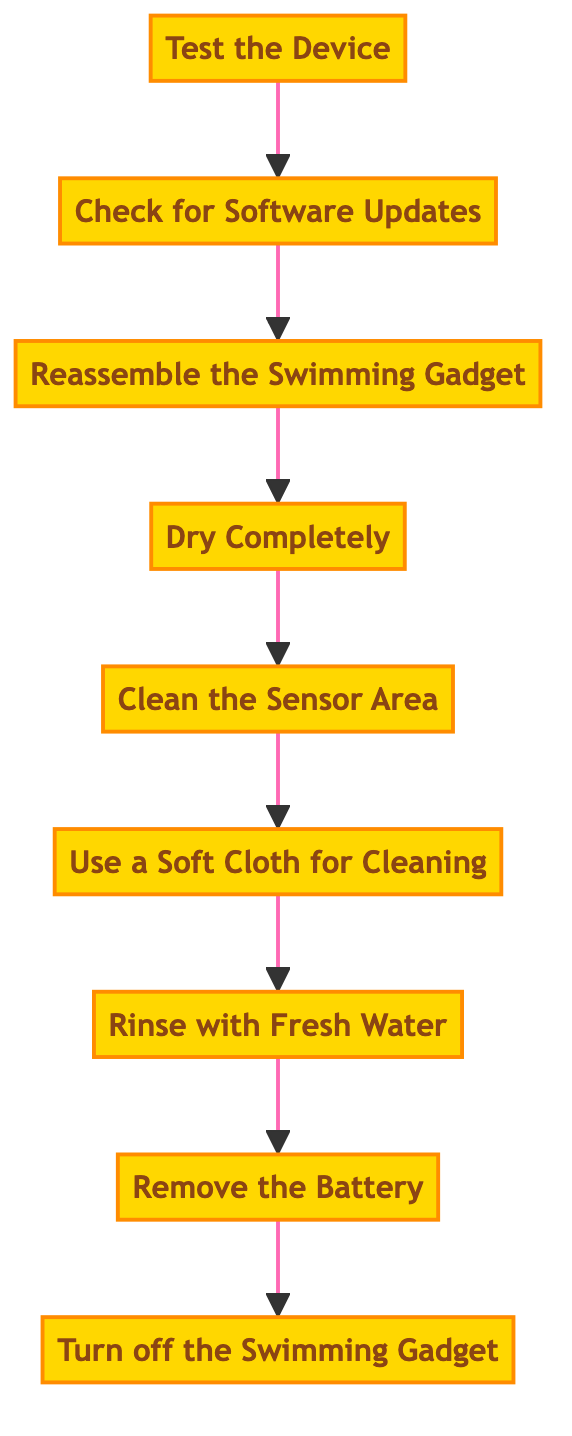What is the first step in the process? The first step in the flow chart is identified at the bottom, which is "Turn off the Swimming Gadget."
Answer: Turn off the Swimming Gadget How many steps are in the maintenance and cleaning process? By counting all listed steps in the flow chart from bottom to top, there are a total of nine distinct steps outlined in the process.
Answer: 9 What should you do before cleaning the device? The instruction before cleaning, according to the flow, is to "Remove the Battery" to ensure safety and prevent short circuits.
Answer: Remove the Battery After rinsing the gadget, what is the next step? Following the "Rinse with Fresh Water" step, the next step that follows in the process is "Use a Soft Cloth for Cleaning."
Answer: Use a Soft Cloth for Cleaning What step involves checking for software updates? The process specifies that "Check for Software Updates" is one of the later steps, which comes after reassembling the gadget.
Answer: Check for Software Updates Which step follows drying the gadget? After the step "Dry Completely," the next step is "Reassemble the Swimming Gadget," indicating the process of putting the device back together.
Answer: Reassemble the Swimming Gadget What is the final step in the maintenance process? The last step as per the flow chart is "Test the Device," which ensures everything is functioning properly after maintenance.
Answer: Test the Device Which cleaning method is recommended for the sensor area? The instruction specifies that a "mild soap solution and a soft brush" should be used for cleaning the sensor area to maintain accurate functionality.
Answer: Mild soap solution and a soft brush What should you avoid using when cleaning the gadget? The instructions advise against using "abrasive materials" when wiping down the gadget to prevent damage.
Answer: Abrasive materials 